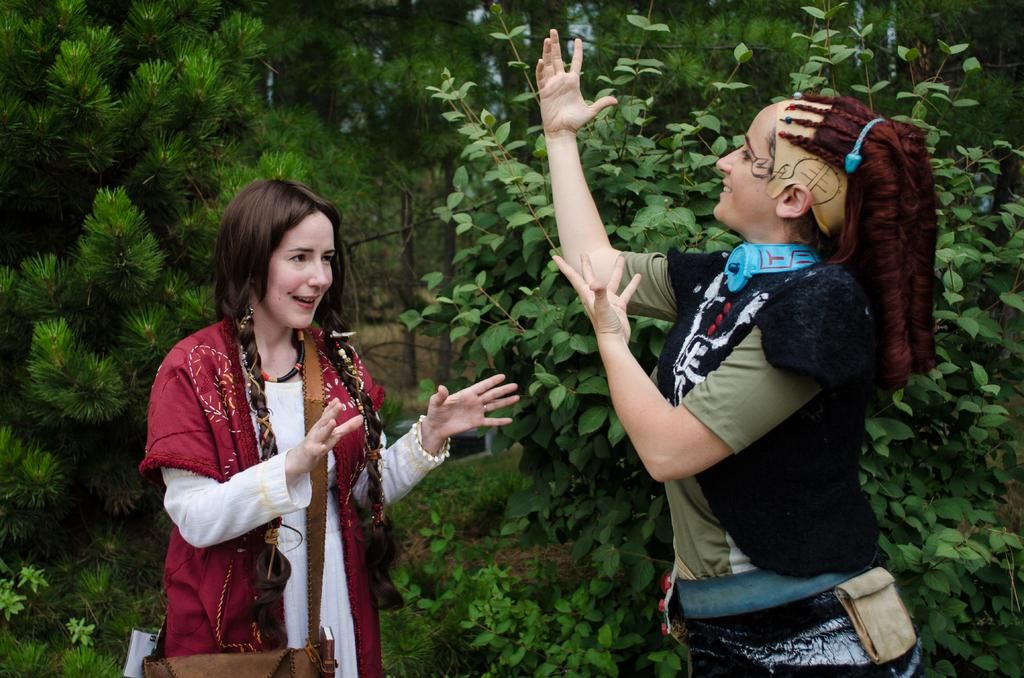Who or what is present in the image? There are people in the image. What are the people wearing? The people are wearing bags. What can be seen in the background of the image? There are trees and poles visible in the background of the image. Can you see any cats or deer near the trees in the image? There are no cats or deer visible in the image; only people, bags, trees, and poles can be seen. 